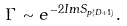<formula> <loc_0><loc_0><loc_500><loc_500>\Gamma \sim e ^ { - 2 I m S _ { p ( D + 1 ) } } .</formula> 